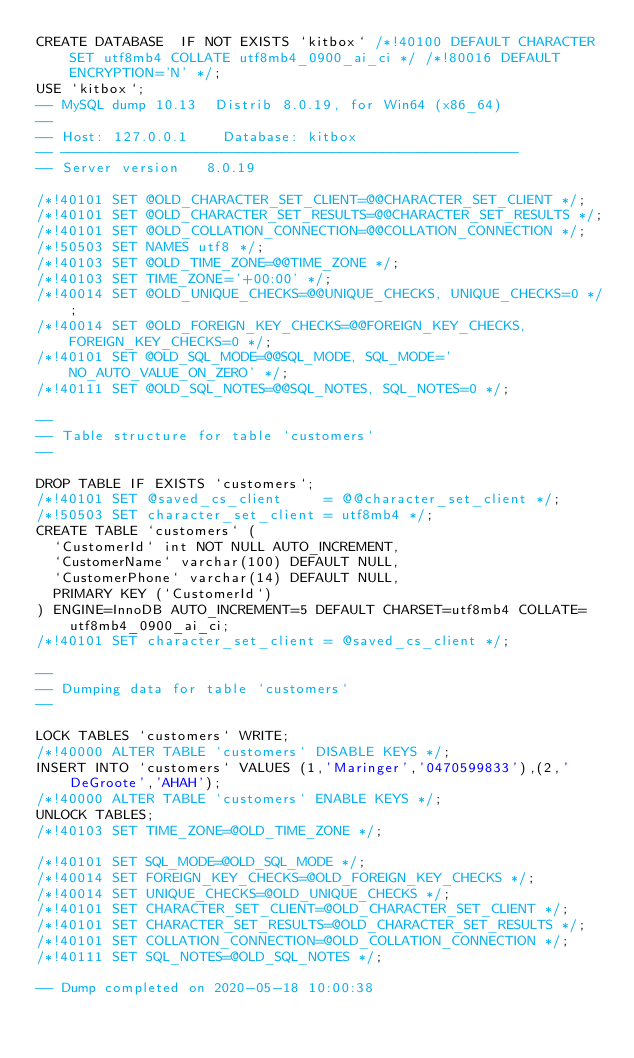Convert code to text. <code><loc_0><loc_0><loc_500><loc_500><_SQL_>CREATE DATABASE  IF NOT EXISTS `kitbox` /*!40100 DEFAULT CHARACTER SET utf8mb4 COLLATE utf8mb4_0900_ai_ci */ /*!80016 DEFAULT ENCRYPTION='N' */;
USE `kitbox`;
-- MySQL dump 10.13  Distrib 8.0.19, for Win64 (x86_64)
--
-- Host: 127.0.0.1    Database: kitbox
-- ------------------------------------------------------
-- Server version	8.0.19

/*!40101 SET @OLD_CHARACTER_SET_CLIENT=@@CHARACTER_SET_CLIENT */;
/*!40101 SET @OLD_CHARACTER_SET_RESULTS=@@CHARACTER_SET_RESULTS */;
/*!40101 SET @OLD_COLLATION_CONNECTION=@@COLLATION_CONNECTION */;
/*!50503 SET NAMES utf8 */;
/*!40103 SET @OLD_TIME_ZONE=@@TIME_ZONE */;
/*!40103 SET TIME_ZONE='+00:00' */;
/*!40014 SET @OLD_UNIQUE_CHECKS=@@UNIQUE_CHECKS, UNIQUE_CHECKS=0 */;
/*!40014 SET @OLD_FOREIGN_KEY_CHECKS=@@FOREIGN_KEY_CHECKS, FOREIGN_KEY_CHECKS=0 */;
/*!40101 SET @OLD_SQL_MODE=@@SQL_MODE, SQL_MODE='NO_AUTO_VALUE_ON_ZERO' */;
/*!40111 SET @OLD_SQL_NOTES=@@SQL_NOTES, SQL_NOTES=0 */;

--
-- Table structure for table `customers`
--

DROP TABLE IF EXISTS `customers`;
/*!40101 SET @saved_cs_client     = @@character_set_client */;
/*!50503 SET character_set_client = utf8mb4 */;
CREATE TABLE `customers` (
  `CustomerId` int NOT NULL AUTO_INCREMENT,
  `CustomerName` varchar(100) DEFAULT NULL,
  `CustomerPhone` varchar(14) DEFAULT NULL,
  PRIMARY KEY (`CustomerId`)
) ENGINE=InnoDB AUTO_INCREMENT=5 DEFAULT CHARSET=utf8mb4 COLLATE=utf8mb4_0900_ai_ci;
/*!40101 SET character_set_client = @saved_cs_client */;

--
-- Dumping data for table `customers`
--

LOCK TABLES `customers` WRITE;
/*!40000 ALTER TABLE `customers` DISABLE KEYS */;
INSERT INTO `customers` VALUES (1,'Maringer','0470599833'),(2,'DeGroote','AHAH');
/*!40000 ALTER TABLE `customers` ENABLE KEYS */;
UNLOCK TABLES;
/*!40103 SET TIME_ZONE=@OLD_TIME_ZONE */;

/*!40101 SET SQL_MODE=@OLD_SQL_MODE */;
/*!40014 SET FOREIGN_KEY_CHECKS=@OLD_FOREIGN_KEY_CHECKS */;
/*!40014 SET UNIQUE_CHECKS=@OLD_UNIQUE_CHECKS */;
/*!40101 SET CHARACTER_SET_CLIENT=@OLD_CHARACTER_SET_CLIENT */;
/*!40101 SET CHARACTER_SET_RESULTS=@OLD_CHARACTER_SET_RESULTS */;
/*!40101 SET COLLATION_CONNECTION=@OLD_COLLATION_CONNECTION */;
/*!40111 SET SQL_NOTES=@OLD_SQL_NOTES */;

-- Dump completed on 2020-05-18 10:00:38
</code> 